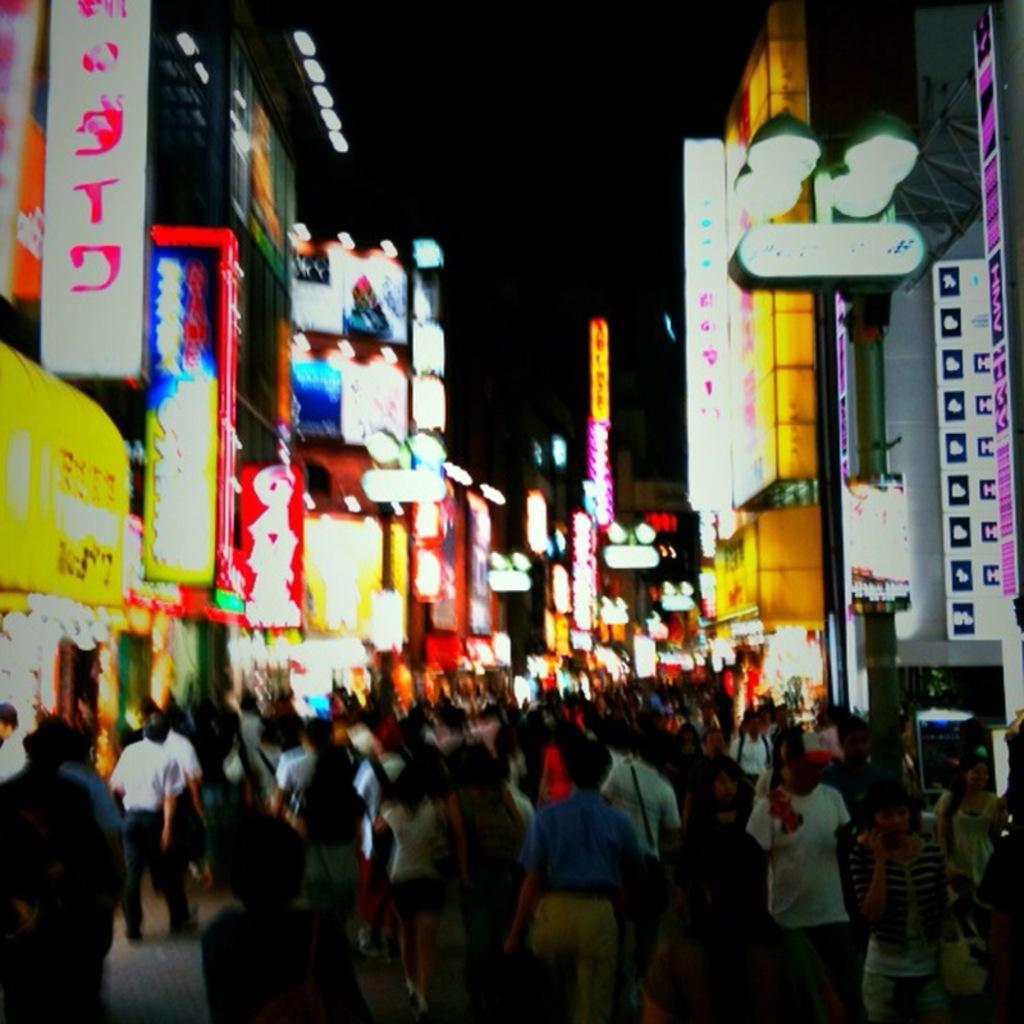What are the people in the image doing? There is a group of persons walking in the center of the image. What can be seen in the background of the image? There are buildings in the background of the image. What else is visible in the image besides the people and buildings? There are lights visible in the image. What might the text on the boards indicate? The boards with text written on them in the image might indicate signs, advertisements, or messages. What type of throat medicine is being advertised on the boards in the image? There is no throat medicine or any reference to medicine on the boards in the image. 